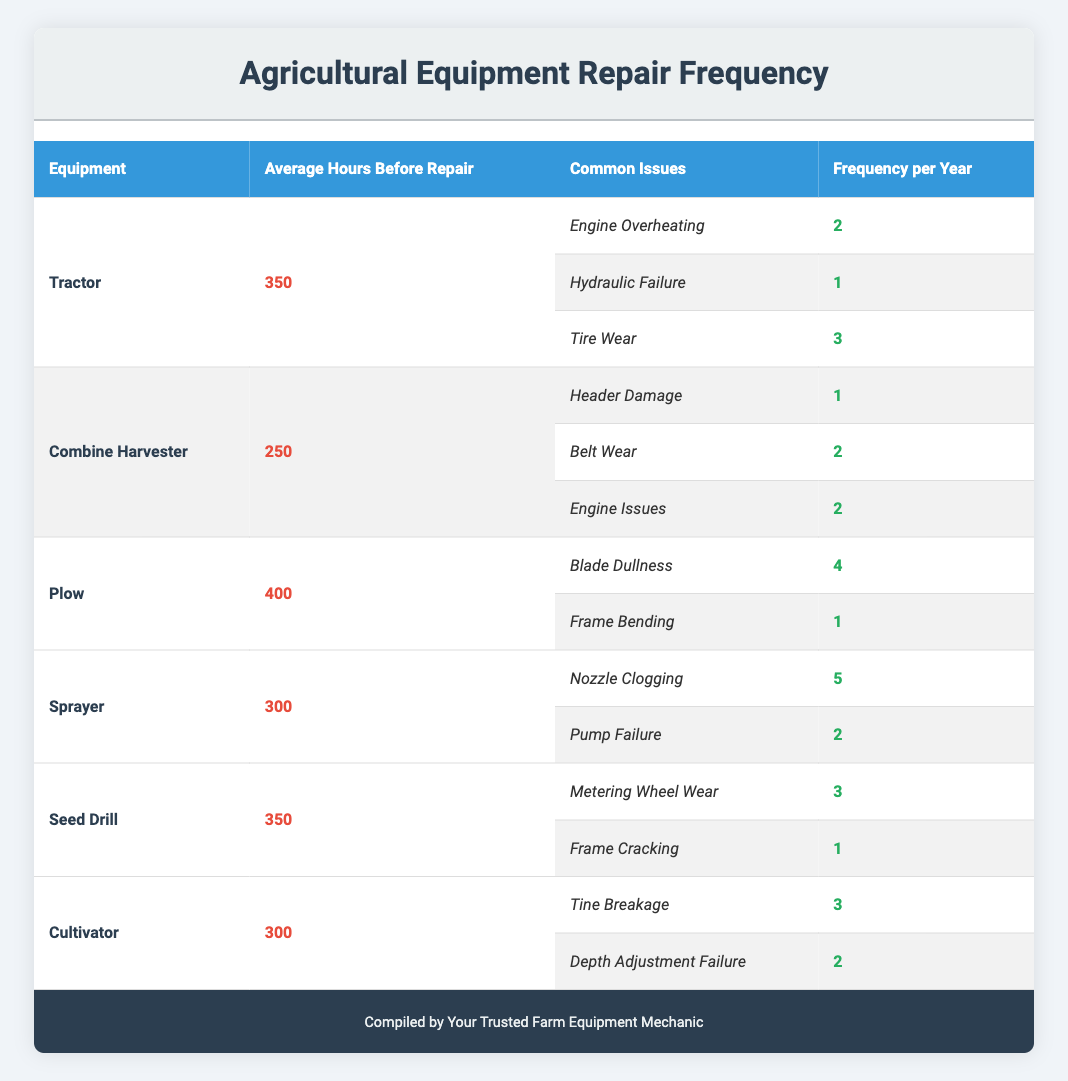What is the most frequent issue reported for the Sprayer? The table shows that the most frequent issue for the Sprayer is "Nozzle Clogging," which occurs 5 times per year.
Answer: Nozzle Clogging How many issues are reported for the Combine Harvester? The Combine Harvester has 3 common issues listed: Header Damage, Belt Wear, and Engine Issues.
Answer: 3 Which piece of equipment requires repairs after the longest average hours of use? The Plow has the highest average hours before repair, at 400 hours.
Answer: Plow What is the total frequency of repairs for the Tractor? The total frequency of repairs for the Tractor is calculated by adding the frequencies: 2 (Engine Overheating) + 1 (Hydraulic Failure) + 3 (Tire Wear) = 6.
Answer: 6 How does the frequency of "Nozzle Clogging" for the Sprayer compare to "Tire Wear" for the Tractor? The Sprayer has a frequency of 5 for Nozzle Clogging, while the Tractor has a frequency of 3 for Tire Wear. Since 5 is greater than 3, Nozzle Clogging occurs more frequently.
Answer: Nozzle Clogging is more frequent Is it true that the Plow has a higher frequency of issues compared to the Combine Harvester? The Plow has a total issue frequency of 5 (4 for Blade Dullness and 1 for Frame Bending), while the Combine Harvester has a total issue frequency of 5 as well (1 for Header Damage, 2 for Belt Wear, and 2 for Engine Issues). Therefore, it is false to say the Plow has a higher frequency.
Answer: No Calculate the average frequency of all issues for Cultivator. For the Cultivator, there are two issues: Tine Breakage (3) and Depth Adjustment Failure (2). The average frequency is (3 + 2) / 2 = 2.5.
Answer: 2.5 Which equipment has the least frequent issue related to its most common problems? The equipment with the least frequent issue among its most common problems is the Combine Harvester with its issue of Header Damage that occurs only once a year.
Answer: Combine Harvester How many common issues have a frequency greater than 2 across all equipment? The issues with a frequency greater than 2 are: Tire Wear (3), Blade Dullness (4), Nozzle Clogging (5), Metering Wheel Wear (3), and Tine Breakage (3). This gives a total of 5 issues.
Answer: 5 What is the combined frequency of repair issues for the Seed Drill? The combined frequency of repair issues for the Seed Drill is 3 (Metering Wheel Wear) + 1 (Frame Cracking) = 4.
Answer: 4 Does the Tractor have more frequent repair issues compared to the Cultivator? The Tractor has a total frequency of 6 (2 + 1 + 3) and the Cultivator has a total frequency of 5 (3 + 2). Therefore, it is true that the Tractor has more frequent repair issues.
Answer: Yes 